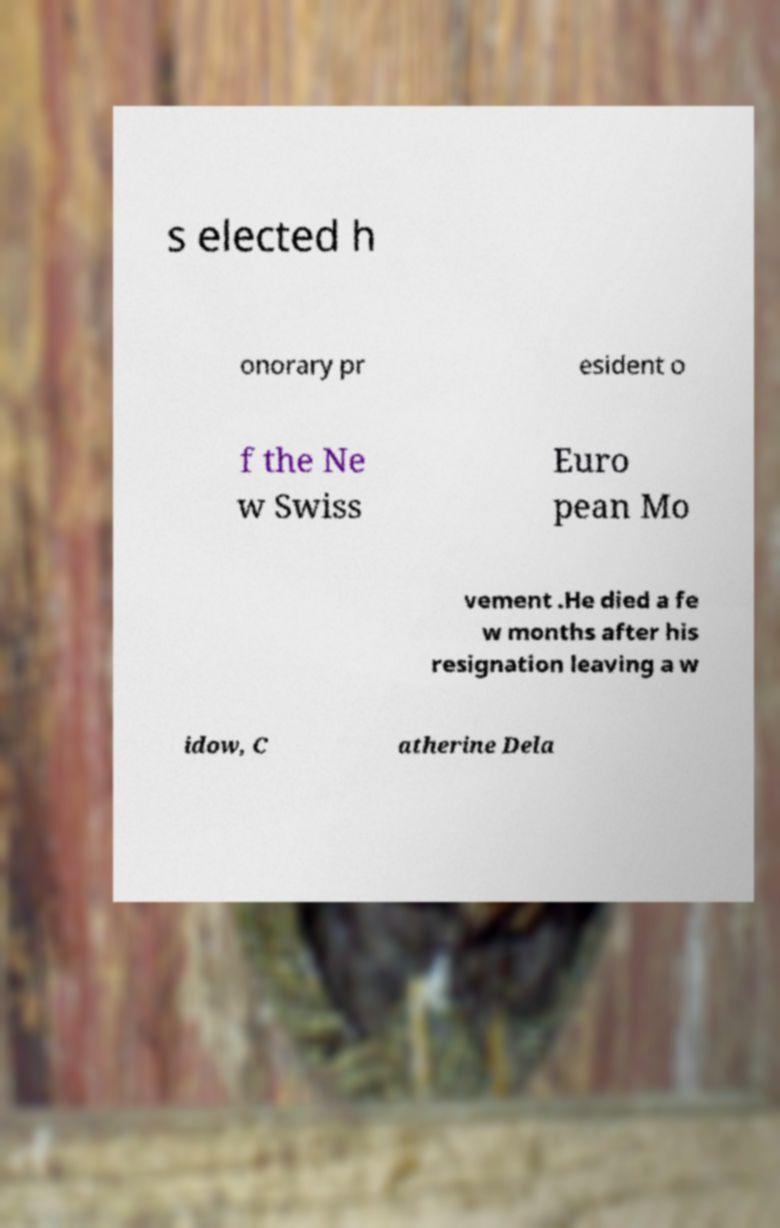What messages or text are displayed in this image? I need them in a readable, typed format. s elected h onorary pr esident o f the Ne w Swiss Euro pean Mo vement .He died a fe w months after his resignation leaving a w idow, C atherine Dela 